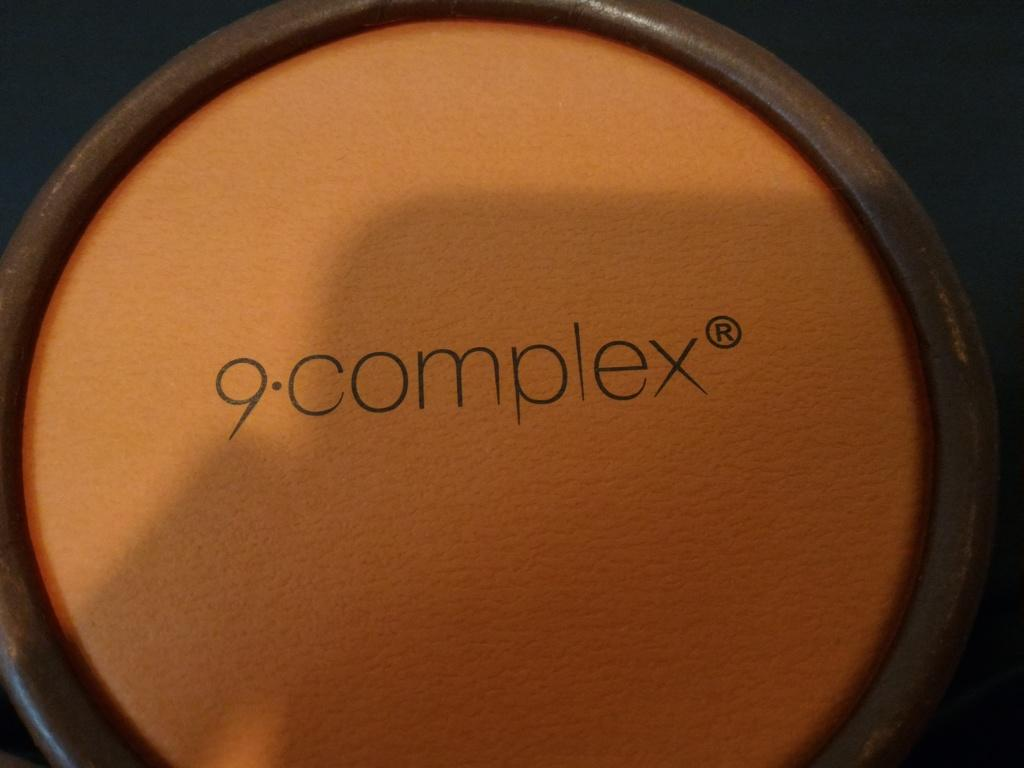<image>
Provide a brief description of the given image. A barrel with the trademark 9 complex is surrounded by a dark background. 